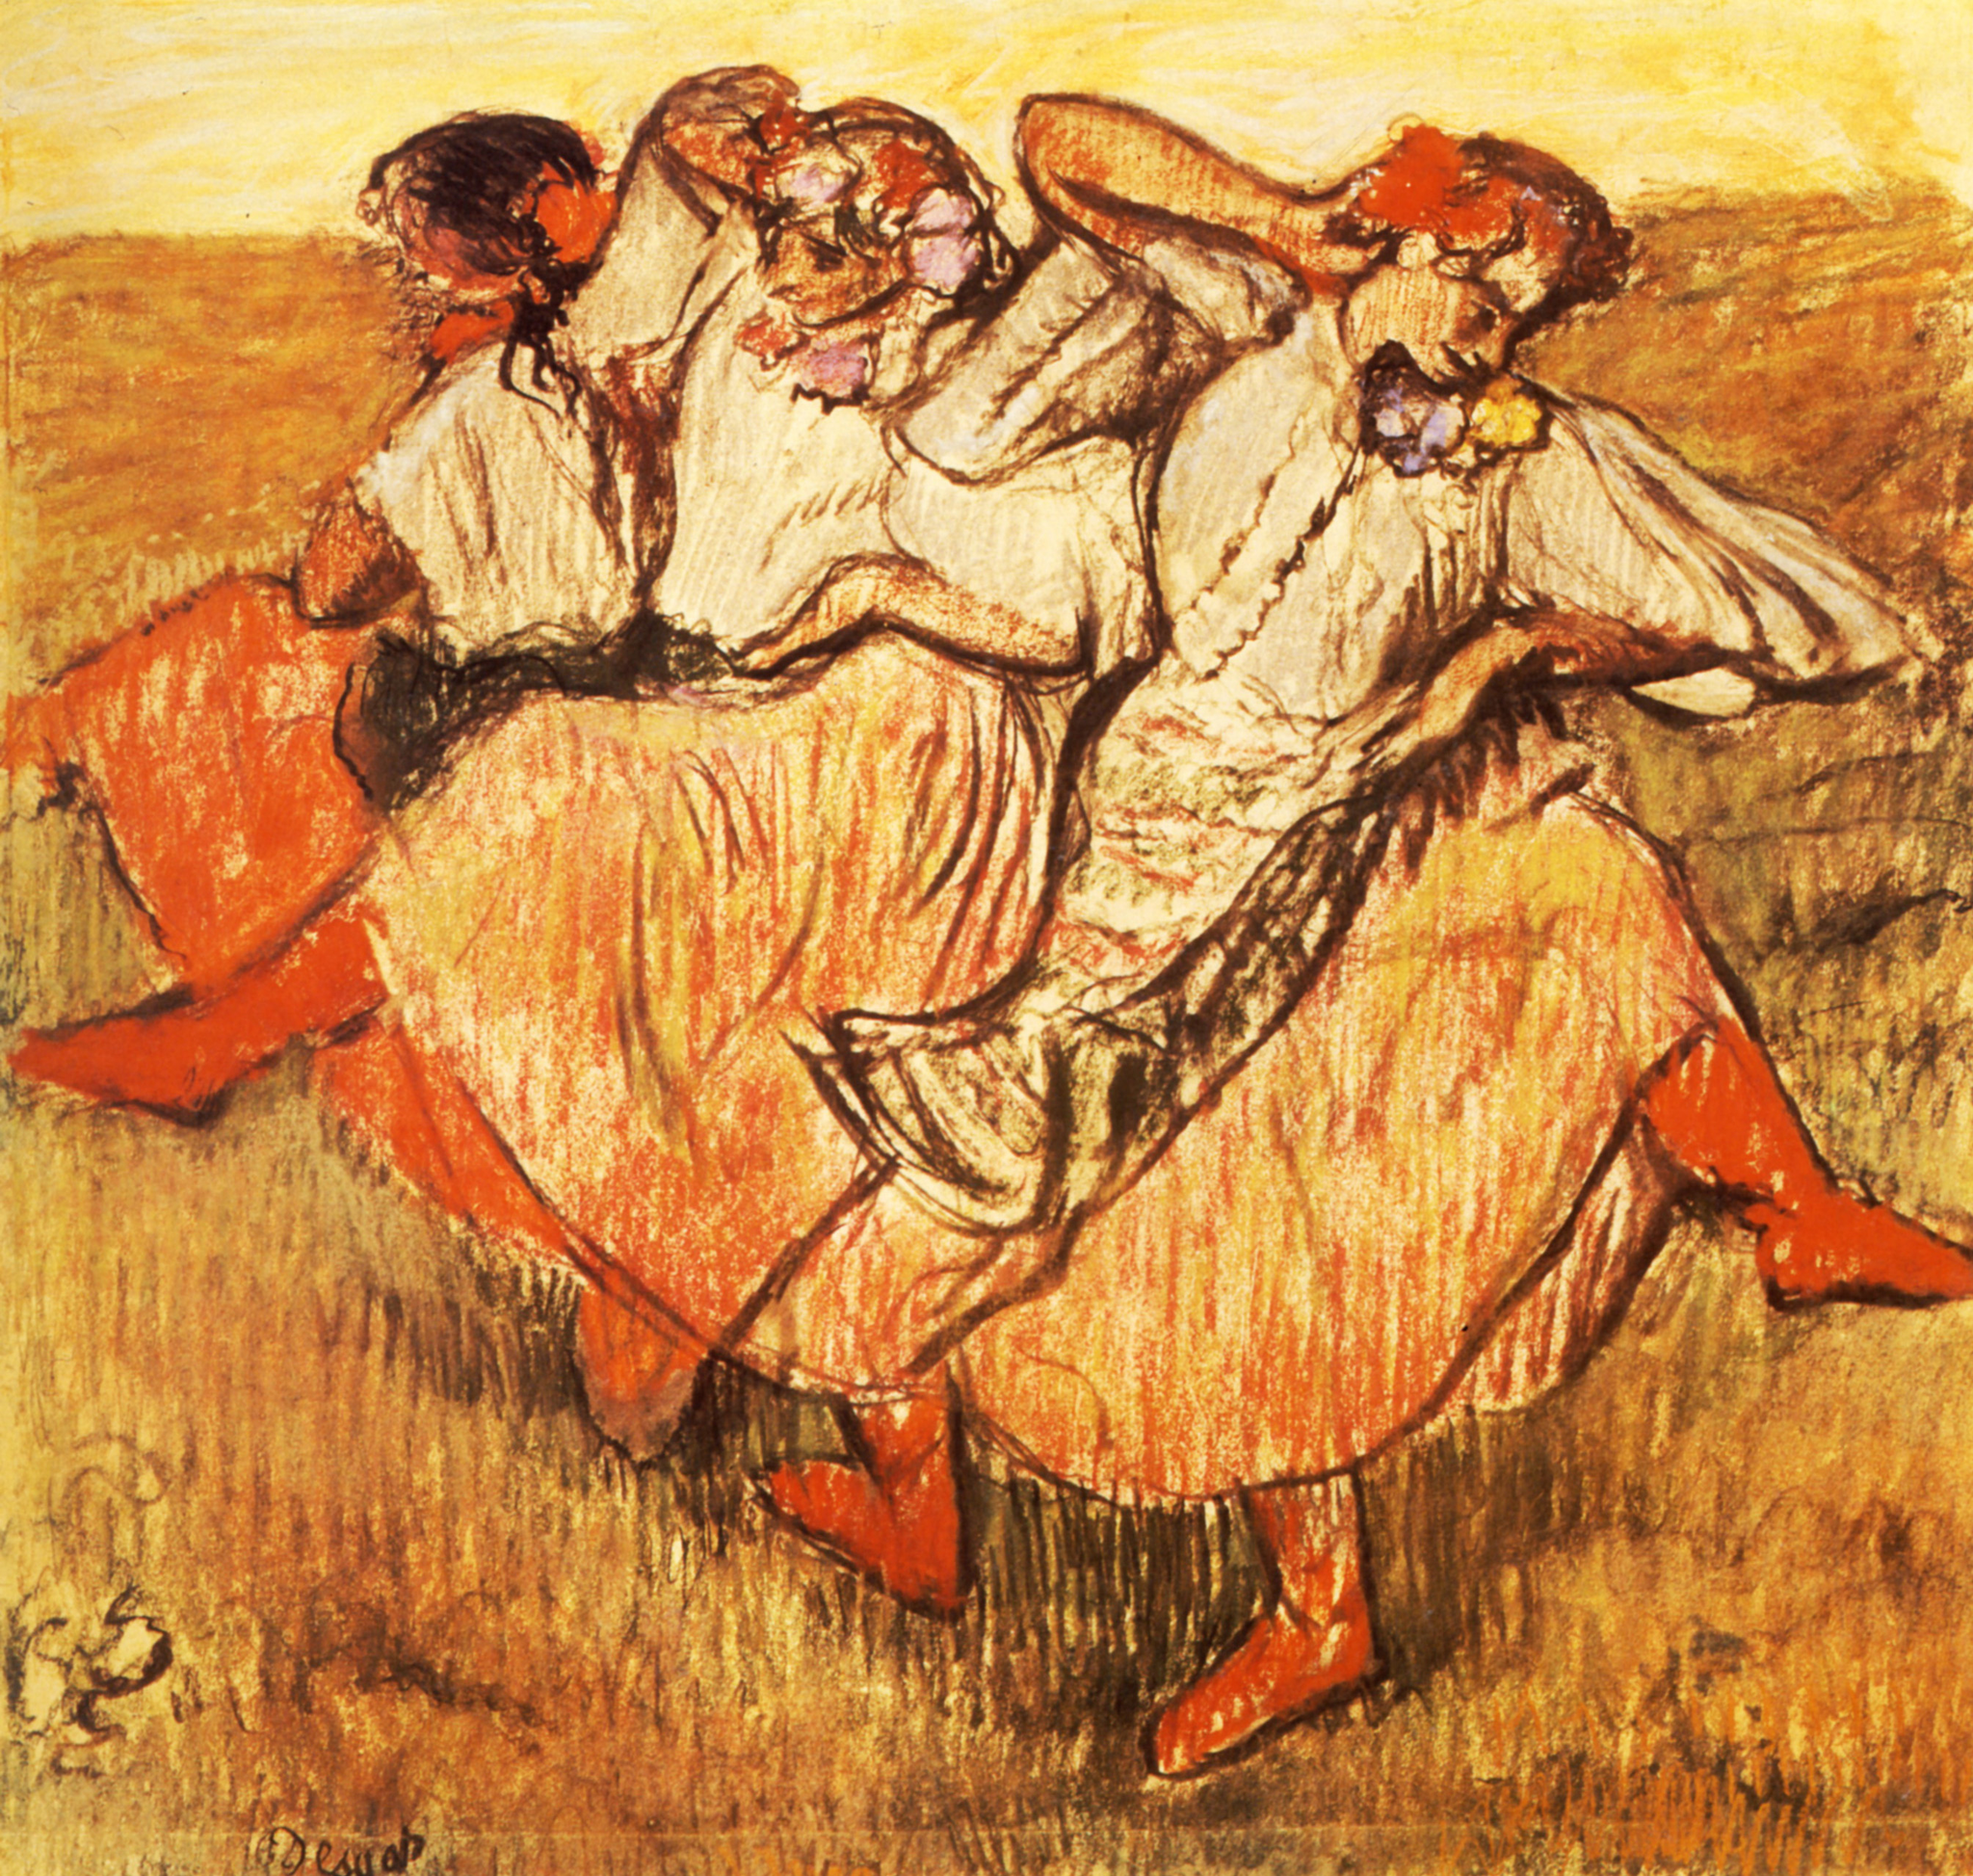Describe the following image. The image is a vibrant impressionist painting capturing a scene of three women dancing in a field. The women are the central figures, each adorned in long, flowing dresses that cascade in shades of orange and white, adding a sense of movement to their dance. The background is a field bathed in a golden yellow hue, possibly indicating tall grass swaying in the breeze. The painting style is loose and sketchy, with visible brushstrokes that add texture and depth to the scene. The overall mood conveyed is one of joy and carefree abandon, as if the women are lost in their dance, oblivious to the world around them. The genre of the painting is impressionism, characterized by its emphasis on capturing the fleeting effects of light and color. 